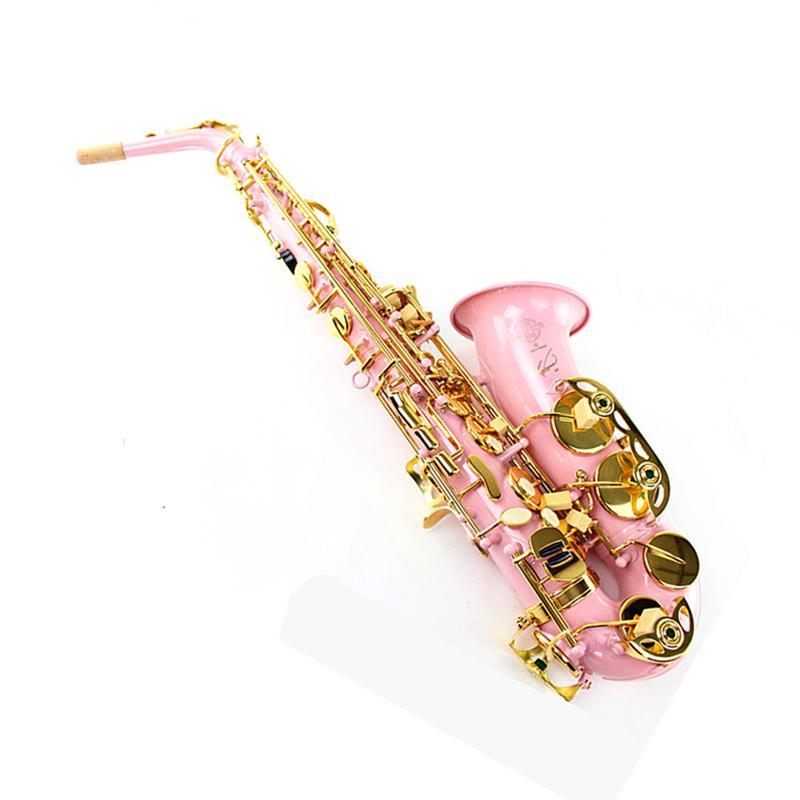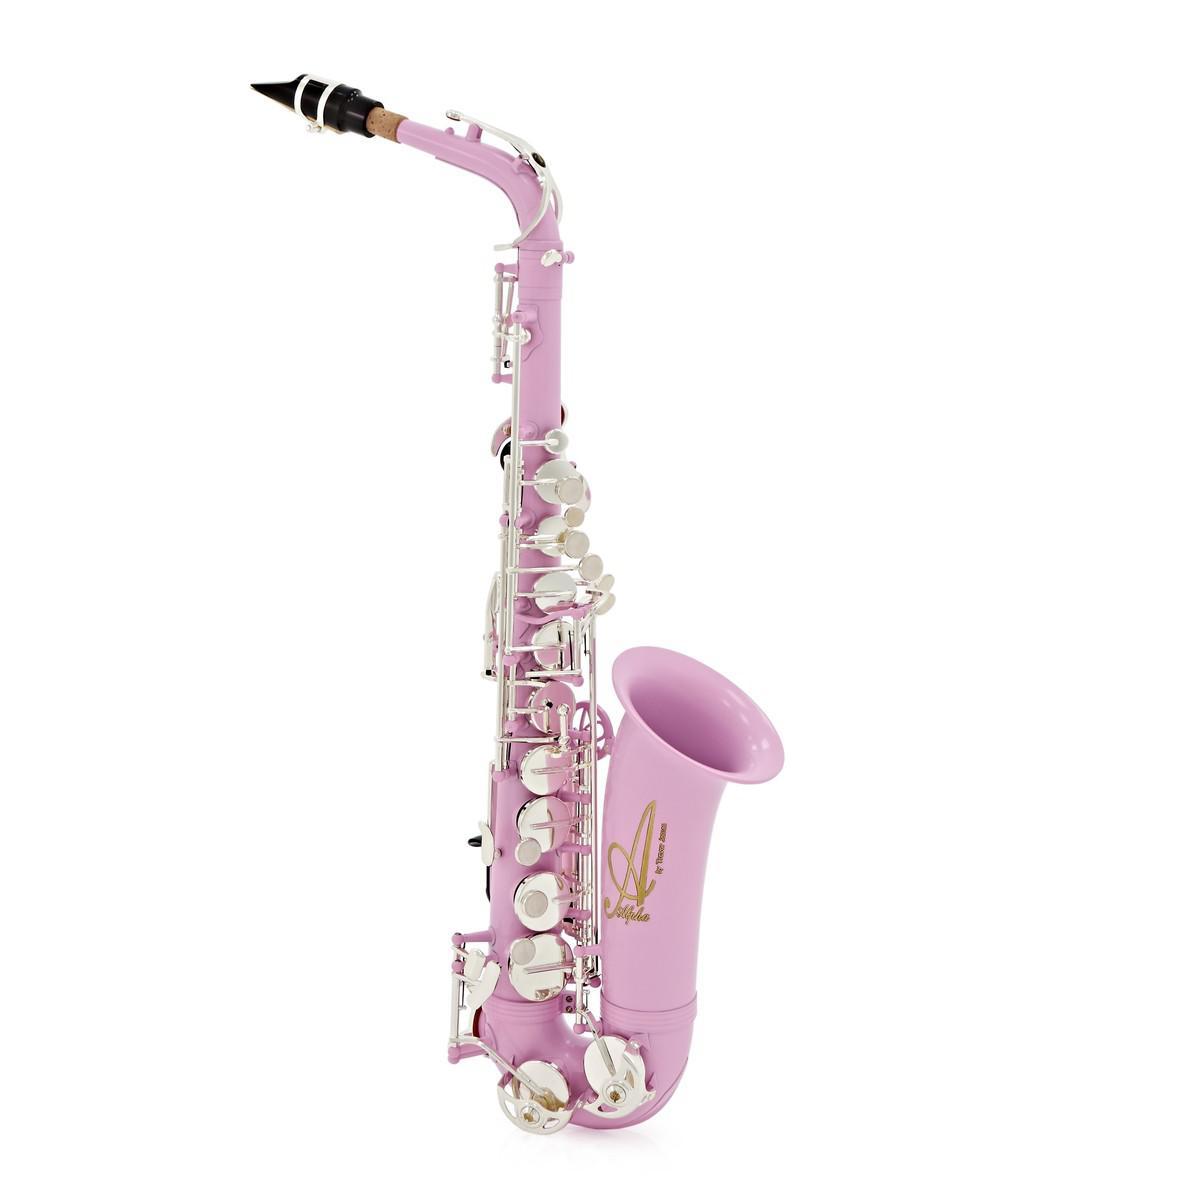The first image is the image on the left, the second image is the image on the right. Evaluate the accuracy of this statement regarding the images: "One saxophone has a traditional metallic colored body, and the other has a body colored some shade of pink.". Is it true? Answer yes or no. No. The first image is the image on the left, the second image is the image on the right. For the images shown, is this caption "Exactly two saxophones are the same size and positioned at the same angle, but are different colors." true? Answer yes or no. No. 